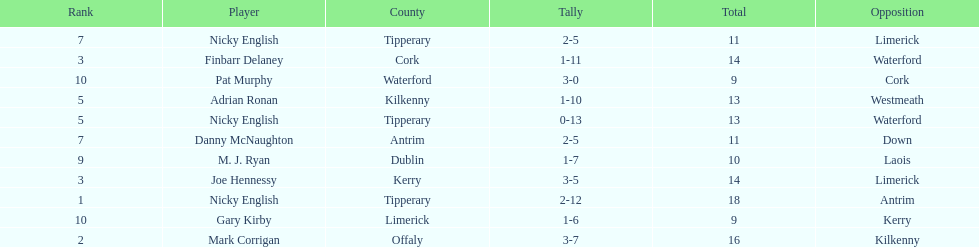What would the sum of all the totals be? 138. 